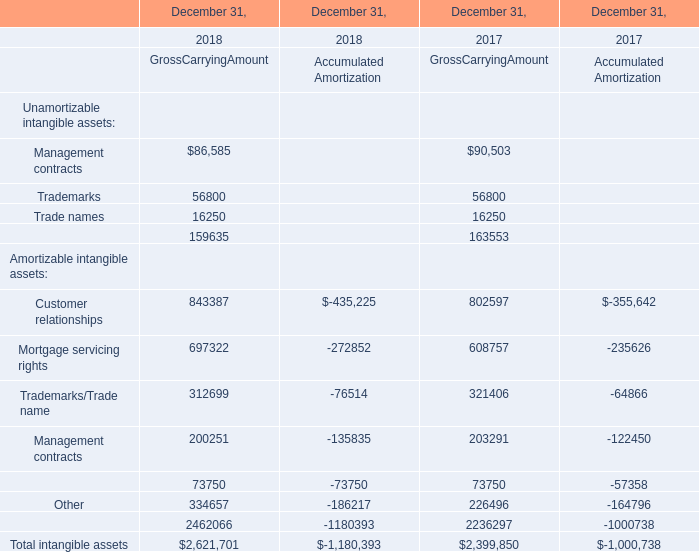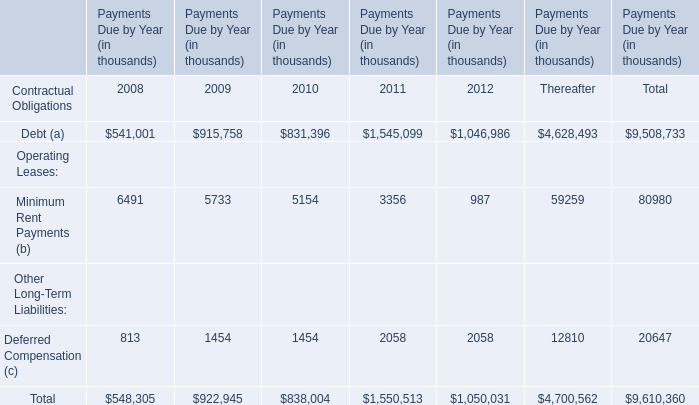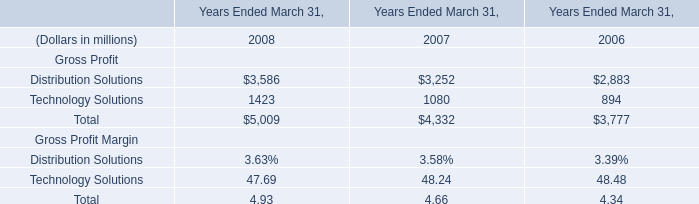Does customer relationships in gross carrying amount keeps increasing each year between 2017 and 2018? 
Answer: yes. 